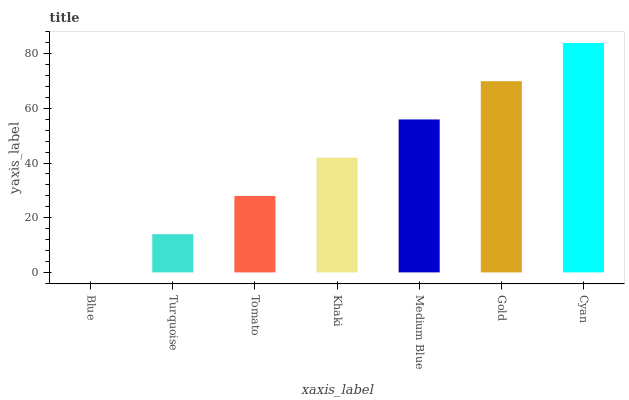Is Blue the minimum?
Answer yes or no. Yes. Is Cyan the maximum?
Answer yes or no. Yes. Is Turquoise the minimum?
Answer yes or no. No. Is Turquoise the maximum?
Answer yes or no. No. Is Turquoise greater than Blue?
Answer yes or no. Yes. Is Blue less than Turquoise?
Answer yes or no. Yes. Is Blue greater than Turquoise?
Answer yes or no. No. Is Turquoise less than Blue?
Answer yes or no. No. Is Khaki the high median?
Answer yes or no. Yes. Is Khaki the low median?
Answer yes or no. Yes. Is Gold the high median?
Answer yes or no. No. Is Blue the low median?
Answer yes or no. No. 